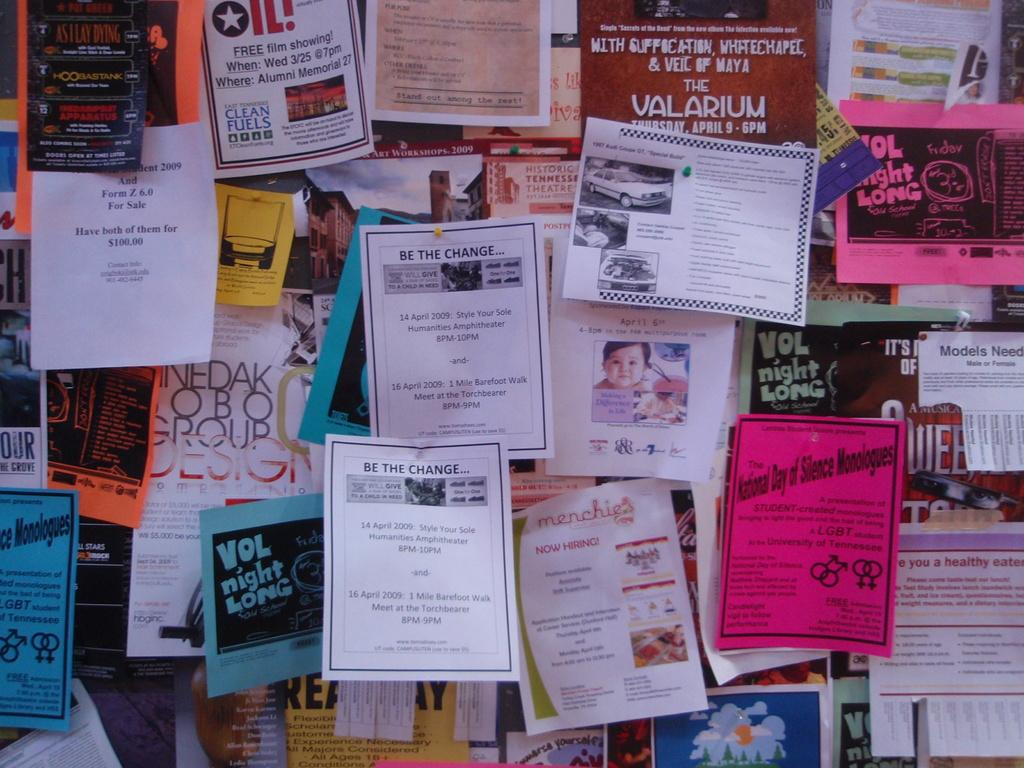Provide a one-sentence caption for the provided image. The pamphlet on the board said ,"Be the Change.". 